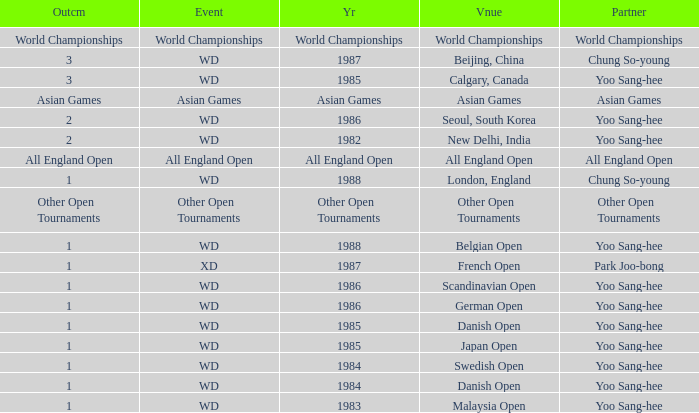What was the Venue in 1986 with an Outcome of 1? Scandinavian Open, German Open. 